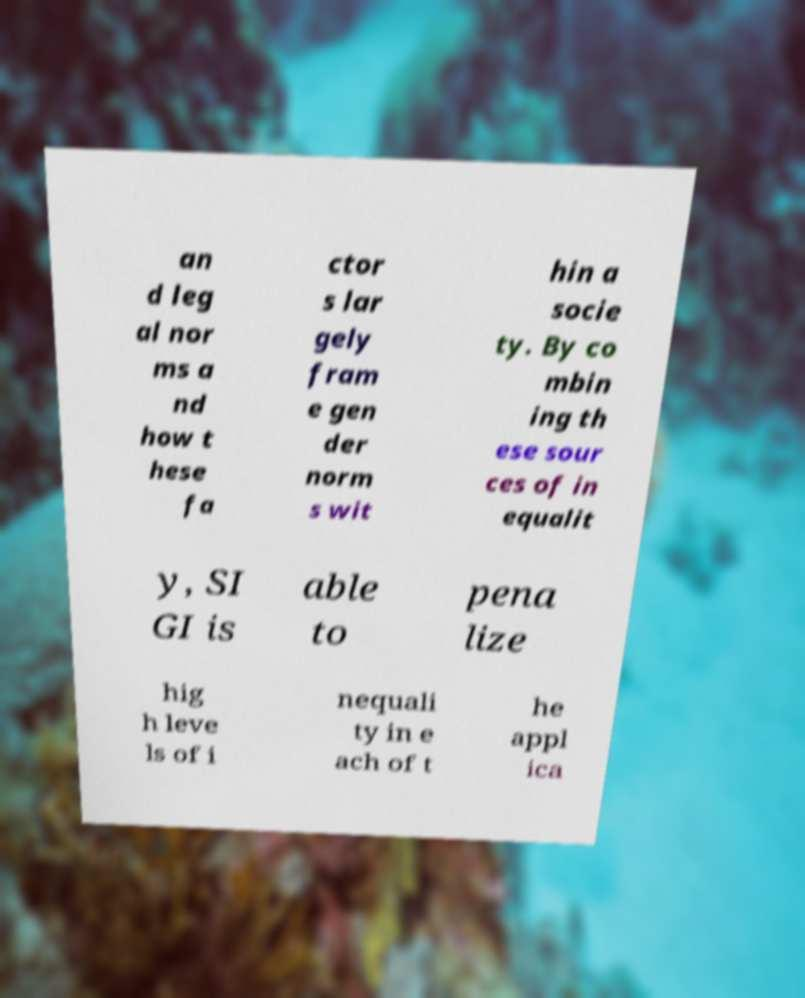For documentation purposes, I need the text within this image transcribed. Could you provide that? an d leg al nor ms a nd how t hese fa ctor s lar gely fram e gen der norm s wit hin a socie ty. By co mbin ing th ese sour ces of in equalit y, SI GI is able to pena lize hig h leve ls of i nequali ty in e ach of t he appl ica 